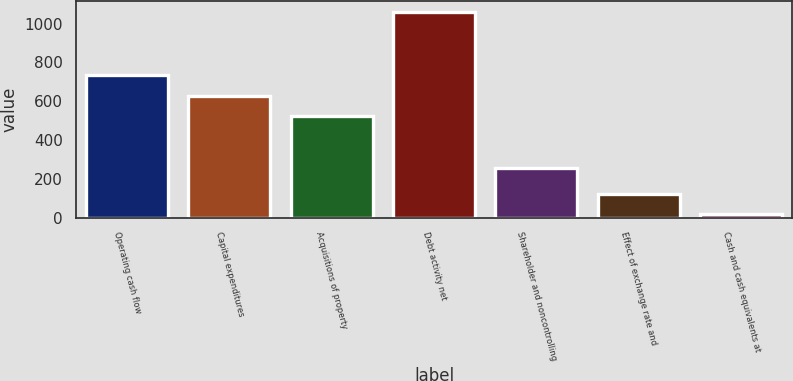Convert chart. <chart><loc_0><loc_0><loc_500><loc_500><bar_chart><fcel>Operating cash flow<fcel>Capital expenditures<fcel>Acquisitions of property<fcel>Debt activity net<fcel>Shareholder and noncontrolling<fcel>Effect of exchange rate and<fcel>Cash and cash equivalents at<nl><fcel>732.6<fcel>628.3<fcel>524<fcel>1061<fcel>254<fcel>122.3<fcel>18<nl></chart> 